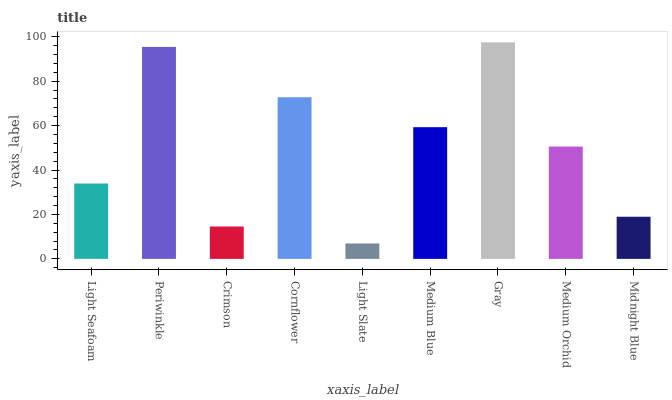Is Light Slate the minimum?
Answer yes or no. Yes. Is Gray the maximum?
Answer yes or no. Yes. Is Periwinkle the minimum?
Answer yes or no. No. Is Periwinkle the maximum?
Answer yes or no. No. Is Periwinkle greater than Light Seafoam?
Answer yes or no. Yes. Is Light Seafoam less than Periwinkle?
Answer yes or no. Yes. Is Light Seafoam greater than Periwinkle?
Answer yes or no. No. Is Periwinkle less than Light Seafoam?
Answer yes or no. No. Is Medium Orchid the high median?
Answer yes or no. Yes. Is Medium Orchid the low median?
Answer yes or no. Yes. Is Light Seafoam the high median?
Answer yes or no. No. Is Cornflower the low median?
Answer yes or no. No. 